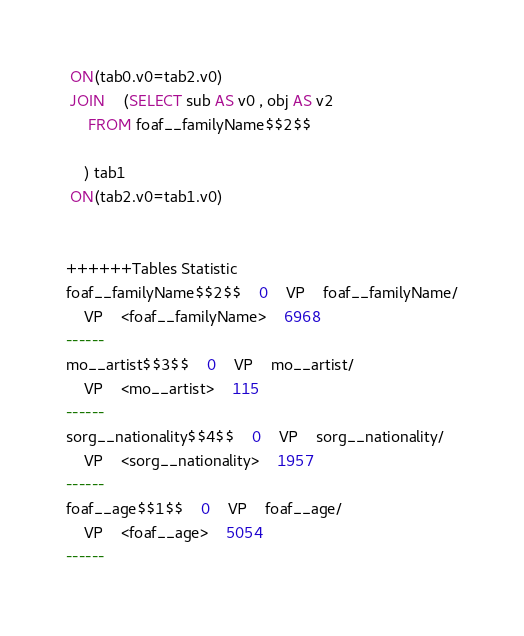Convert code to text. <code><loc_0><loc_0><loc_500><loc_500><_SQL_> ON(tab0.v0=tab2.v0)
 JOIN    (SELECT sub AS v0 , obj AS v2 
	 FROM foaf__familyName$$2$$
	
	) tab1
 ON(tab2.v0=tab1.v0)


++++++Tables Statistic
foaf__familyName$$2$$	0	VP	foaf__familyName/
	VP	<foaf__familyName>	6968
------
mo__artist$$3$$	0	VP	mo__artist/
	VP	<mo__artist>	115
------
sorg__nationality$$4$$	0	VP	sorg__nationality/
	VP	<sorg__nationality>	1957
------
foaf__age$$1$$	0	VP	foaf__age/
	VP	<foaf__age>	5054
------
</code> 